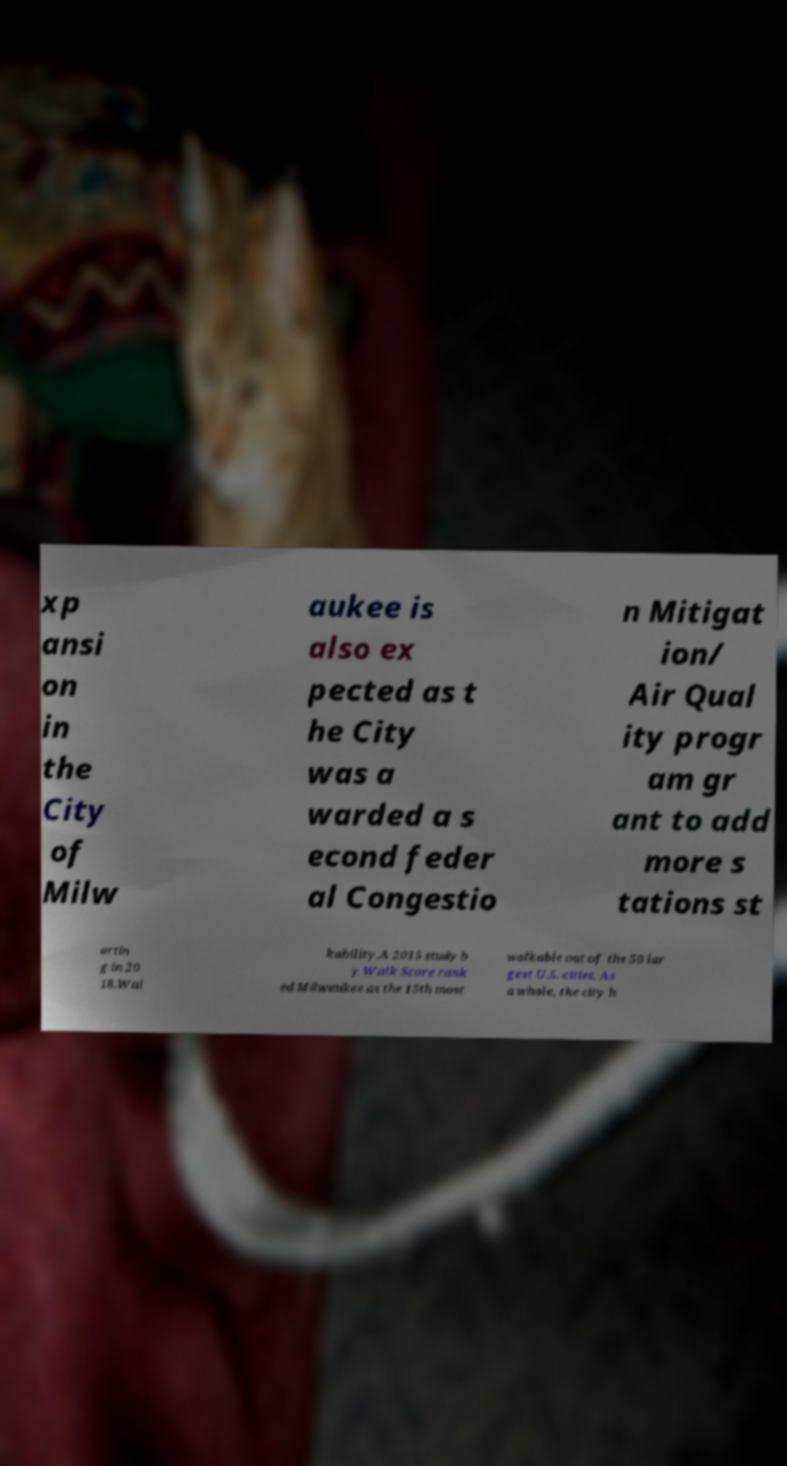Please read and relay the text visible in this image. What does it say? xp ansi on in the City of Milw aukee is also ex pected as t he City was a warded a s econd feder al Congestio n Mitigat ion/ Air Qual ity progr am gr ant to add more s tations st artin g in 20 18.Wal kability.A 2015 study b y Walk Score rank ed Milwaukee as the 15th most walkable out of the 50 lar gest U.S. cities. As a whole, the city h 